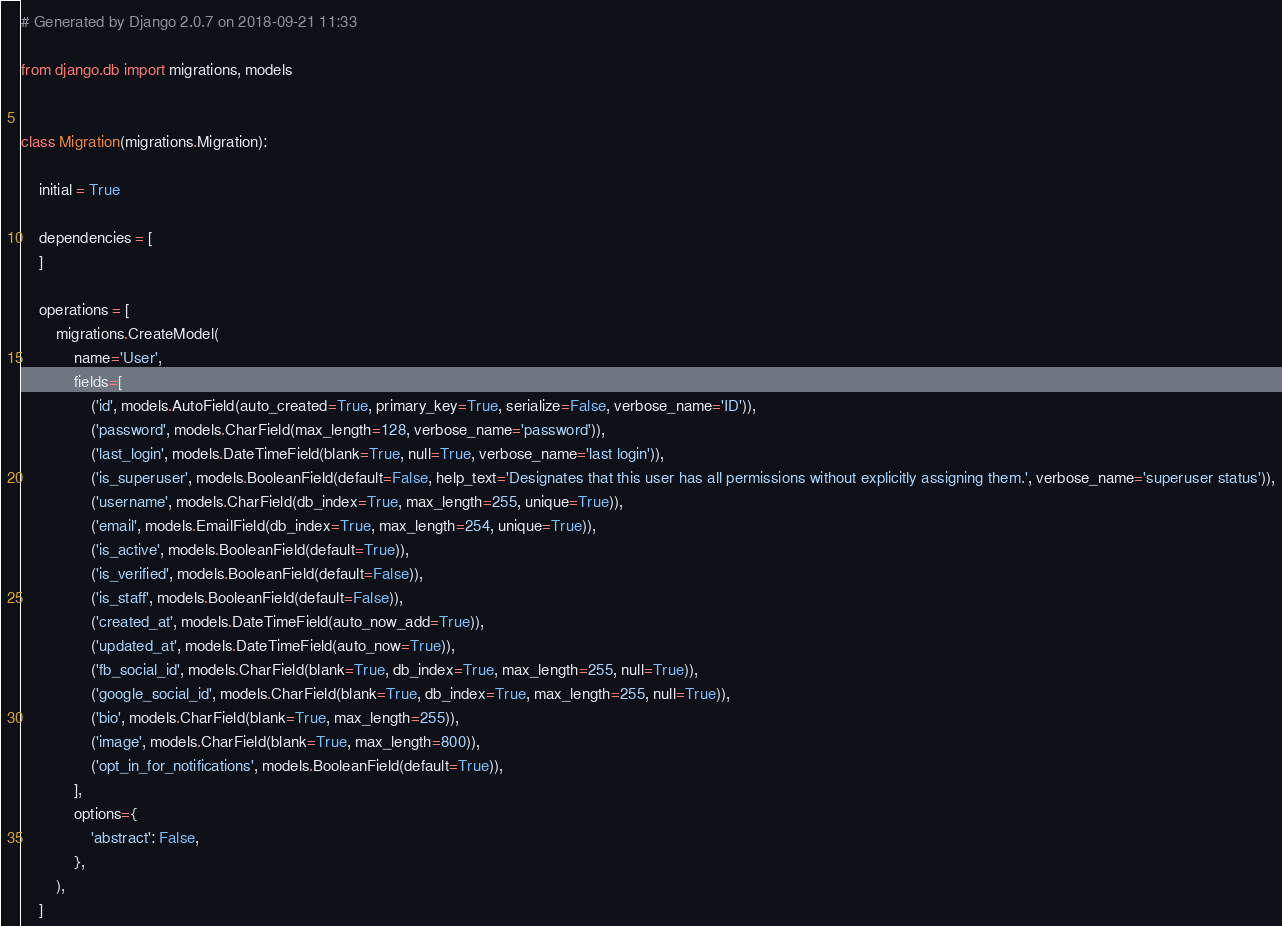Convert code to text. <code><loc_0><loc_0><loc_500><loc_500><_Python_># Generated by Django 2.0.7 on 2018-09-21 11:33

from django.db import migrations, models


class Migration(migrations.Migration):

    initial = True

    dependencies = [
    ]

    operations = [
        migrations.CreateModel(
            name='User',
            fields=[
                ('id', models.AutoField(auto_created=True, primary_key=True, serialize=False, verbose_name='ID')),
                ('password', models.CharField(max_length=128, verbose_name='password')),
                ('last_login', models.DateTimeField(blank=True, null=True, verbose_name='last login')),
                ('is_superuser', models.BooleanField(default=False, help_text='Designates that this user has all permissions without explicitly assigning them.', verbose_name='superuser status')),
                ('username', models.CharField(db_index=True, max_length=255, unique=True)),
                ('email', models.EmailField(db_index=True, max_length=254, unique=True)),
                ('is_active', models.BooleanField(default=True)),
                ('is_verified', models.BooleanField(default=False)),
                ('is_staff', models.BooleanField(default=False)),
                ('created_at', models.DateTimeField(auto_now_add=True)),
                ('updated_at', models.DateTimeField(auto_now=True)),
                ('fb_social_id', models.CharField(blank=True, db_index=True, max_length=255, null=True)),
                ('google_social_id', models.CharField(blank=True, db_index=True, max_length=255, null=True)),
                ('bio', models.CharField(blank=True, max_length=255)),
                ('image', models.CharField(blank=True, max_length=800)),
                ('opt_in_for_notifications', models.BooleanField(default=True)),
            ],
            options={
                'abstract': False,
            },
        ),
    ]
</code> 